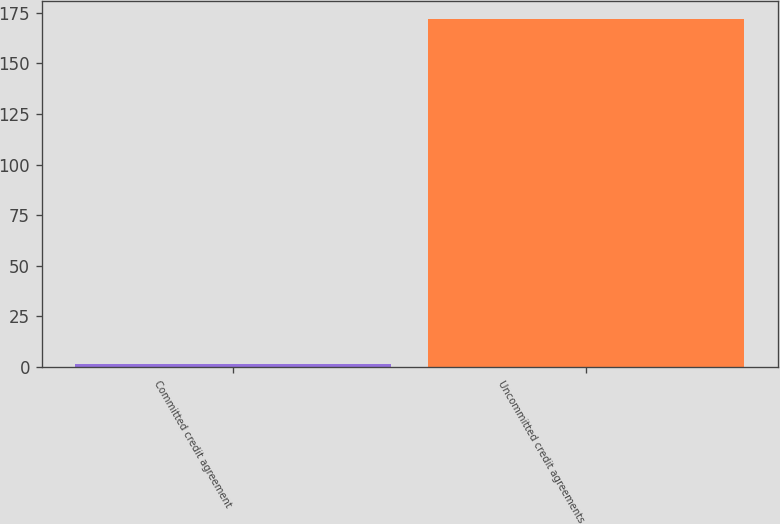<chart> <loc_0><loc_0><loc_500><loc_500><bar_chart><fcel>Committed credit agreement<fcel>Uncommitted credit agreements<nl><fcel>1.24<fcel>172.1<nl></chart> 